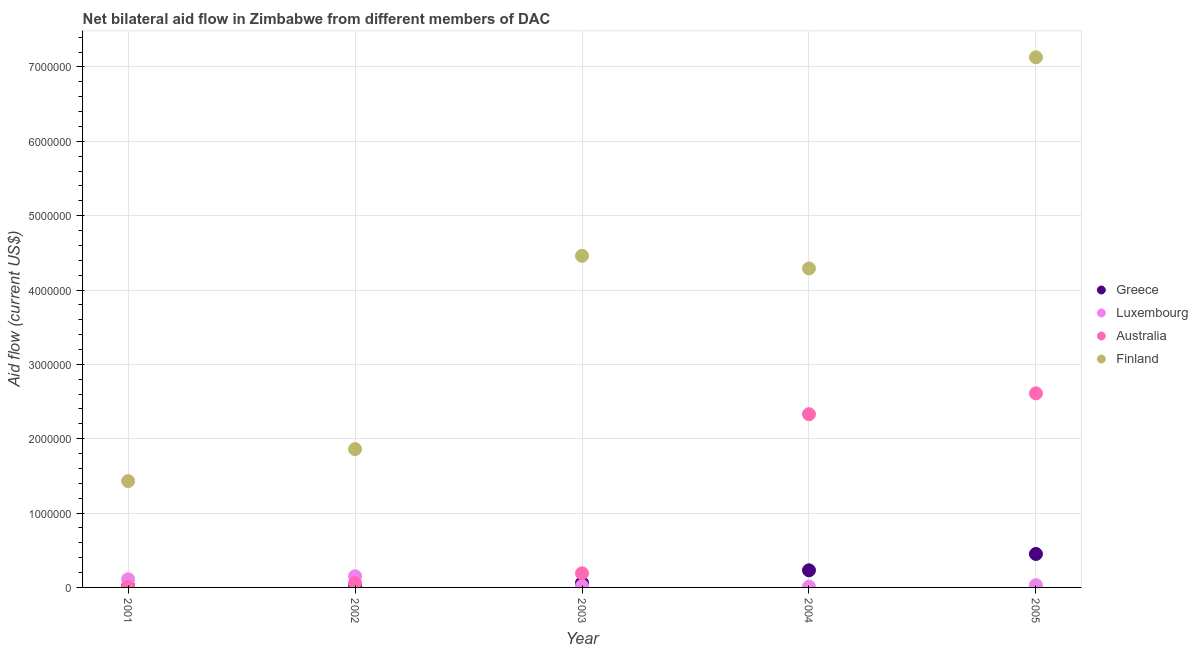What is the amount of aid given by finland in 2002?
Give a very brief answer. 1.86e+06. Across all years, what is the maximum amount of aid given by greece?
Give a very brief answer. 4.50e+05. Across all years, what is the minimum amount of aid given by finland?
Your answer should be very brief. 1.43e+06. In which year was the amount of aid given by luxembourg maximum?
Provide a short and direct response. 2002. What is the total amount of aid given by finland in the graph?
Your response must be concise. 1.92e+07. What is the difference between the amount of aid given by australia in 2003 and that in 2004?
Offer a very short reply. -2.14e+06. What is the difference between the amount of aid given by finland in 2003 and the amount of aid given by greece in 2002?
Offer a very short reply. 4.44e+06. What is the average amount of aid given by finland per year?
Make the answer very short. 3.83e+06. In the year 2005, what is the difference between the amount of aid given by finland and amount of aid given by australia?
Give a very brief answer. 4.52e+06. In how many years, is the amount of aid given by greece greater than 1800000 US$?
Give a very brief answer. 0. What is the ratio of the amount of aid given by greece in 2001 to that in 2003?
Your answer should be compact. 0.33. What is the difference between the highest and the second highest amount of aid given by greece?
Ensure brevity in your answer.  2.20e+05. What is the difference between the highest and the lowest amount of aid given by australia?
Offer a very short reply. 2.60e+06. In how many years, is the amount of aid given by australia greater than the average amount of aid given by australia taken over all years?
Offer a very short reply. 2. Is it the case that in every year, the sum of the amount of aid given by greece and amount of aid given by luxembourg is greater than the amount of aid given by australia?
Make the answer very short. No. Does the amount of aid given by finland monotonically increase over the years?
Your answer should be very brief. No. Is the amount of aid given by luxembourg strictly less than the amount of aid given by finland over the years?
Provide a short and direct response. Yes. How many dotlines are there?
Make the answer very short. 4. What is the difference between two consecutive major ticks on the Y-axis?
Keep it short and to the point. 1.00e+06. Are the values on the major ticks of Y-axis written in scientific E-notation?
Your answer should be compact. No. Does the graph contain any zero values?
Your answer should be very brief. No. What is the title of the graph?
Provide a short and direct response. Net bilateral aid flow in Zimbabwe from different members of DAC. What is the label or title of the Y-axis?
Make the answer very short. Aid flow (current US$). What is the Aid flow (current US$) in Finland in 2001?
Provide a succinct answer. 1.43e+06. What is the Aid flow (current US$) in Luxembourg in 2002?
Provide a short and direct response. 1.50e+05. What is the Aid flow (current US$) of Australia in 2002?
Your answer should be compact. 6.00e+04. What is the Aid flow (current US$) in Finland in 2002?
Provide a short and direct response. 1.86e+06. What is the Aid flow (current US$) of Greece in 2003?
Keep it short and to the point. 6.00e+04. What is the Aid flow (current US$) in Australia in 2003?
Provide a short and direct response. 1.90e+05. What is the Aid flow (current US$) in Finland in 2003?
Keep it short and to the point. 4.46e+06. What is the Aid flow (current US$) of Australia in 2004?
Keep it short and to the point. 2.33e+06. What is the Aid flow (current US$) of Finland in 2004?
Provide a succinct answer. 4.29e+06. What is the Aid flow (current US$) in Australia in 2005?
Ensure brevity in your answer.  2.61e+06. What is the Aid flow (current US$) in Finland in 2005?
Your answer should be very brief. 7.13e+06. Across all years, what is the maximum Aid flow (current US$) in Luxembourg?
Your response must be concise. 1.50e+05. Across all years, what is the maximum Aid flow (current US$) in Australia?
Your answer should be very brief. 2.61e+06. Across all years, what is the maximum Aid flow (current US$) in Finland?
Give a very brief answer. 7.13e+06. Across all years, what is the minimum Aid flow (current US$) in Greece?
Provide a succinct answer. 2.00e+04. Across all years, what is the minimum Aid flow (current US$) of Luxembourg?
Your answer should be very brief. 10000. Across all years, what is the minimum Aid flow (current US$) in Finland?
Your answer should be very brief. 1.43e+06. What is the total Aid flow (current US$) of Greece in the graph?
Your answer should be compact. 7.80e+05. What is the total Aid flow (current US$) in Luxembourg in the graph?
Provide a succinct answer. 3.20e+05. What is the total Aid flow (current US$) in Australia in the graph?
Make the answer very short. 5.20e+06. What is the total Aid flow (current US$) of Finland in the graph?
Your response must be concise. 1.92e+07. What is the difference between the Aid flow (current US$) in Greece in 2001 and that in 2002?
Your response must be concise. 0. What is the difference between the Aid flow (current US$) of Luxembourg in 2001 and that in 2002?
Keep it short and to the point. -4.00e+04. What is the difference between the Aid flow (current US$) of Australia in 2001 and that in 2002?
Keep it short and to the point. -5.00e+04. What is the difference between the Aid flow (current US$) in Finland in 2001 and that in 2002?
Ensure brevity in your answer.  -4.30e+05. What is the difference between the Aid flow (current US$) in Finland in 2001 and that in 2003?
Make the answer very short. -3.03e+06. What is the difference between the Aid flow (current US$) of Greece in 2001 and that in 2004?
Offer a very short reply. -2.10e+05. What is the difference between the Aid flow (current US$) in Luxembourg in 2001 and that in 2004?
Ensure brevity in your answer.  1.00e+05. What is the difference between the Aid flow (current US$) in Australia in 2001 and that in 2004?
Your response must be concise. -2.32e+06. What is the difference between the Aid flow (current US$) of Finland in 2001 and that in 2004?
Make the answer very short. -2.86e+06. What is the difference between the Aid flow (current US$) of Greece in 2001 and that in 2005?
Offer a very short reply. -4.30e+05. What is the difference between the Aid flow (current US$) of Luxembourg in 2001 and that in 2005?
Provide a succinct answer. 8.00e+04. What is the difference between the Aid flow (current US$) in Australia in 2001 and that in 2005?
Make the answer very short. -2.60e+06. What is the difference between the Aid flow (current US$) in Finland in 2001 and that in 2005?
Provide a short and direct response. -5.70e+06. What is the difference between the Aid flow (current US$) of Greece in 2002 and that in 2003?
Offer a very short reply. -4.00e+04. What is the difference between the Aid flow (current US$) in Australia in 2002 and that in 2003?
Give a very brief answer. -1.30e+05. What is the difference between the Aid flow (current US$) in Finland in 2002 and that in 2003?
Give a very brief answer. -2.60e+06. What is the difference between the Aid flow (current US$) of Australia in 2002 and that in 2004?
Your answer should be very brief. -2.27e+06. What is the difference between the Aid flow (current US$) in Finland in 2002 and that in 2004?
Provide a short and direct response. -2.43e+06. What is the difference between the Aid flow (current US$) in Greece in 2002 and that in 2005?
Your answer should be very brief. -4.30e+05. What is the difference between the Aid flow (current US$) of Luxembourg in 2002 and that in 2005?
Provide a short and direct response. 1.20e+05. What is the difference between the Aid flow (current US$) in Australia in 2002 and that in 2005?
Ensure brevity in your answer.  -2.55e+06. What is the difference between the Aid flow (current US$) of Finland in 2002 and that in 2005?
Your response must be concise. -5.27e+06. What is the difference between the Aid flow (current US$) of Luxembourg in 2003 and that in 2004?
Your answer should be very brief. 10000. What is the difference between the Aid flow (current US$) of Australia in 2003 and that in 2004?
Ensure brevity in your answer.  -2.14e+06. What is the difference between the Aid flow (current US$) in Finland in 2003 and that in 2004?
Offer a terse response. 1.70e+05. What is the difference between the Aid flow (current US$) in Greece in 2003 and that in 2005?
Your answer should be very brief. -3.90e+05. What is the difference between the Aid flow (current US$) of Australia in 2003 and that in 2005?
Offer a terse response. -2.42e+06. What is the difference between the Aid flow (current US$) of Finland in 2003 and that in 2005?
Provide a short and direct response. -2.67e+06. What is the difference between the Aid flow (current US$) in Luxembourg in 2004 and that in 2005?
Ensure brevity in your answer.  -2.00e+04. What is the difference between the Aid flow (current US$) in Australia in 2004 and that in 2005?
Make the answer very short. -2.80e+05. What is the difference between the Aid flow (current US$) of Finland in 2004 and that in 2005?
Provide a succinct answer. -2.84e+06. What is the difference between the Aid flow (current US$) in Greece in 2001 and the Aid flow (current US$) in Luxembourg in 2002?
Your answer should be compact. -1.30e+05. What is the difference between the Aid flow (current US$) of Greece in 2001 and the Aid flow (current US$) of Australia in 2002?
Make the answer very short. -4.00e+04. What is the difference between the Aid flow (current US$) in Greece in 2001 and the Aid flow (current US$) in Finland in 2002?
Offer a terse response. -1.84e+06. What is the difference between the Aid flow (current US$) of Luxembourg in 2001 and the Aid flow (current US$) of Finland in 2002?
Make the answer very short. -1.75e+06. What is the difference between the Aid flow (current US$) of Australia in 2001 and the Aid flow (current US$) of Finland in 2002?
Make the answer very short. -1.85e+06. What is the difference between the Aid flow (current US$) of Greece in 2001 and the Aid flow (current US$) of Luxembourg in 2003?
Ensure brevity in your answer.  0. What is the difference between the Aid flow (current US$) of Greece in 2001 and the Aid flow (current US$) of Finland in 2003?
Ensure brevity in your answer.  -4.44e+06. What is the difference between the Aid flow (current US$) in Luxembourg in 2001 and the Aid flow (current US$) in Australia in 2003?
Ensure brevity in your answer.  -8.00e+04. What is the difference between the Aid flow (current US$) of Luxembourg in 2001 and the Aid flow (current US$) of Finland in 2003?
Offer a very short reply. -4.35e+06. What is the difference between the Aid flow (current US$) in Australia in 2001 and the Aid flow (current US$) in Finland in 2003?
Your response must be concise. -4.45e+06. What is the difference between the Aid flow (current US$) of Greece in 2001 and the Aid flow (current US$) of Luxembourg in 2004?
Provide a short and direct response. 10000. What is the difference between the Aid flow (current US$) of Greece in 2001 and the Aid flow (current US$) of Australia in 2004?
Offer a terse response. -2.31e+06. What is the difference between the Aid flow (current US$) in Greece in 2001 and the Aid flow (current US$) in Finland in 2004?
Keep it short and to the point. -4.27e+06. What is the difference between the Aid flow (current US$) of Luxembourg in 2001 and the Aid flow (current US$) of Australia in 2004?
Keep it short and to the point. -2.22e+06. What is the difference between the Aid flow (current US$) of Luxembourg in 2001 and the Aid flow (current US$) of Finland in 2004?
Offer a terse response. -4.18e+06. What is the difference between the Aid flow (current US$) in Australia in 2001 and the Aid flow (current US$) in Finland in 2004?
Offer a very short reply. -4.28e+06. What is the difference between the Aid flow (current US$) of Greece in 2001 and the Aid flow (current US$) of Australia in 2005?
Offer a very short reply. -2.59e+06. What is the difference between the Aid flow (current US$) in Greece in 2001 and the Aid flow (current US$) in Finland in 2005?
Make the answer very short. -7.11e+06. What is the difference between the Aid flow (current US$) in Luxembourg in 2001 and the Aid flow (current US$) in Australia in 2005?
Provide a succinct answer. -2.50e+06. What is the difference between the Aid flow (current US$) in Luxembourg in 2001 and the Aid flow (current US$) in Finland in 2005?
Give a very brief answer. -7.02e+06. What is the difference between the Aid flow (current US$) of Australia in 2001 and the Aid flow (current US$) of Finland in 2005?
Your response must be concise. -7.12e+06. What is the difference between the Aid flow (current US$) of Greece in 2002 and the Aid flow (current US$) of Luxembourg in 2003?
Offer a terse response. 0. What is the difference between the Aid flow (current US$) in Greece in 2002 and the Aid flow (current US$) in Australia in 2003?
Provide a short and direct response. -1.70e+05. What is the difference between the Aid flow (current US$) in Greece in 2002 and the Aid flow (current US$) in Finland in 2003?
Offer a very short reply. -4.44e+06. What is the difference between the Aid flow (current US$) in Luxembourg in 2002 and the Aid flow (current US$) in Australia in 2003?
Offer a very short reply. -4.00e+04. What is the difference between the Aid flow (current US$) in Luxembourg in 2002 and the Aid flow (current US$) in Finland in 2003?
Your answer should be very brief. -4.31e+06. What is the difference between the Aid flow (current US$) in Australia in 2002 and the Aid flow (current US$) in Finland in 2003?
Your response must be concise. -4.40e+06. What is the difference between the Aid flow (current US$) of Greece in 2002 and the Aid flow (current US$) of Australia in 2004?
Your answer should be compact. -2.31e+06. What is the difference between the Aid flow (current US$) of Greece in 2002 and the Aid flow (current US$) of Finland in 2004?
Provide a succinct answer. -4.27e+06. What is the difference between the Aid flow (current US$) in Luxembourg in 2002 and the Aid flow (current US$) in Australia in 2004?
Provide a short and direct response. -2.18e+06. What is the difference between the Aid flow (current US$) in Luxembourg in 2002 and the Aid flow (current US$) in Finland in 2004?
Ensure brevity in your answer.  -4.14e+06. What is the difference between the Aid flow (current US$) in Australia in 2002 and the Aid flow (current US$) in Finland in 2004?
Keep it short and to the point. -4.23e+06. What is the difference between the Aid flow (current US$) in Greece in 2002 and the Aid flow (current US$) in Australia in 2005?
Ensure brevity in your answer.  -2.59e+06. What is the difference between the Aid flow (current US$) in Greece in 2002 and the Aid flow (current US$) in Finland in 2005?
Your response must be concise. -7.11e+06. What is the difference between the Aid flow (current US$) of Luxembourg in 2002 and the Aid flow (current US$) of Australia in 2005?
Provide a succinct answer. -2.46e+06. What is the difference between the Aid flow (current US$) of Luxembourg in 2002 and the Aid flow (current US$) of Finland in 2005?
Your answer should be very brief. -6.98e+06. What is the difference between the Aid flow (current US$) of Australia in 2002 and the Aid flow (current US$) of Finland in 2005?
Provide a succinct answer. -7.07e+06. What is the difference between the Aid flow (current US$) in Greece in 2003 and the Aid flow (current US$) in Australia in 2004?
Keep it short and to the point. -2.27e+06. What is the difference between the Aid flow (current US$) in Greece in 2003 and the Aid flow (current US$) in Finland in 2004?
Keep it short and to the point. -4.23e+06. What is the difference between the Aid flow (current US$) in Luxembourg in 2003 and the Aid flow (current US$) in Australia in 2004?
Your response must be concise. -2.31e+06. What is the difference between the Aid flow (current US$) of Luxembourg in 2003 and the Aid flow (current US$) of Finland in 2004?
Your answer should be very brief. -4.27e+06. What is the difference between the Aid flow (current US$) in Australia in 2003 and the Aid flow (current US$) in Finland in 2004?
Give a very brief answer. -4.10e+06. What is the difference between the Aid flow (current US$) in Greece in 2003 and the Aid flow (current US$) in Luxembourg in 2005?
Give a very brief answer. 3.00e+04. What is the difference between the Aid flow (current US$) in Greece in 2003 and the Aid flow (current US$) in Australia in 2005?
Provide a short and direct response. -2.55e+06. What is the difference between the Aid flow (current US$) of Greece in 2003 and the Aid flow (current US$) of Finland in 2005?
Your response must be concise. -7.07e+06. What is the difference between the Aid flow (current US$) in Luxembourg in 2003 and the Aid flow (current US$) in Australia in 2005?
Your answer should be compact. -2.59e+06. What is the difference between the Aid flow (current US$) of Luxembourg in 2003 and the Aid flow (current US$) of Finland in 2005?
Give a very brief answer. -7.11e+06. What is the difference between the Aid flow (current US$) of Australia in 2003 and the Aid flow (current US$) of Finland in 2005?
Offer a very short reply. -6.94e+06. What is the difference between the Aid flow (current US$) of Greece in 2004 and the Aid flow (current US$) of Australia in 2005?
Your response must be concise. -2.38e+06. What is the difference between the Aid flow (current US$) of Greece in 2004 and the Aid flow (current US$) of Finland in 2005?
Your answer should be very brief. -6.90e+06. What is the difference between the Aid flow (current US$) in Luxembourg in 2004 and the Aid flow (current US$) in Australia in 2005?
Your answer should be compact. -2.60e+06. What is the difference between the Aid flow (current US$) of Luxembourg in 2004 and the Aid flow (current US$) of Finland in 2005?
Give a very brief answer. -7.12e+06. What is the difference between the Aid flow (current US$) in Australia in 2004 and the Aid flow (current US$) in Finland in 2005?
Offer a very short reply. -4.80e+06. What is the average Aid flow (current US$) in Greece per year?
Keep it short and to the point. 1.56e+05. What is the average Aid flow (current US$) in Luxembourg per year?
Keep it short and to the point. 6.40e+04. What is the average Aid flow (current US$) of Australia per year?
Provide a succinct answer. 1.04e+06. What is the average Aid flow (current US$) of Finland per year?
Your response must be concise. 3.83e+06. In the year 2001, what is the difference between the Aid flow (current US$) in Greece and Aid flow (current US$) in Australia?
Your answer should be very brief. 10000. In the year 2001, what is the difference between the Aid flow (current US$) in Greece and Aid flow (current US$) in Finland?
Give a very brief answer. -1.41e+06. In the year 2001, what is the difference between the Aid flow (current US$) of Luxembourg and Aid flow (current US$) of Australia?
Make the answer very short. 1.00e+05. In the year 2001, what is the difference between the Aid flow (current US$) in Luxembourg and Aid flow (current US$) in Finland?
Provide a succinct answer. -1.32e+06. In the year 2001, what is the difference between the Aid flow (current US$) in Australia and Aid flow (current US$) in Finland?
Offer a terse response. -1.42e+06. In the year 2002, what is the difference between the Aid flow (current US$) of Greece and Aid flow (current US$) of Finland?
Keep it short and to the point. -1.84e+06. In the year 2002, what is the difference between the Aid flow (current US$) of Luxembourg and Aid flow (current US$) of Finland?
Ensure brevity in your answer.  -1.71e+06. In the year 2002, what is the difference between the Aid flow (current US$) of Australia and Aid flow (current US$) of Finland?
Keep it short and to the point. -1.80e+06. In the year 2003, what is the difference between the Aid flow (current US$) in Greece and Aid flow (current US$) in Luxembourg?
Give a very brief answer. 4.00e+04. In the year 2003, what is the difference between the Aid flow (current US$) in Greece and Aid flow (current US$) in Australia?
Ensure brevity in your answer.  -1.30e+05. In the year 2003, what is the difference between the Aid flow (current US$) in Greece and Aid flow (current US$) in Finland?
Give a very brief answer. -4.40e+06. In the year 2003, what is the difference between the Aid flow (current US$) in Luxembourg and Aid flow (current US$) in Australia?
Offer a very short reply. -1.70e+05. In the year 2003, what is the difference between the Aid flow (current US$) in Luxembourg and Aid flow (current US$) in Finland?
Your answer should be very brief. -4.44e+06. In the year 2003, what is the difference between the Aid flow (current US$) of Australia and Aid flow (current US$) of Finland?
Provide a short and direct response. -4.27e+06. In the year 2004, what is the difference between the Aid flow (current US$) of Greece and Aid flow (current US$) of Australia?
Make the answer very short. -2.10e+06. In the year 2004, what is the difference between the Aid flow (current US$) in Greece and Aid flow (current US$) in Finland?
Make the answer very short. -4.06e+06. In the year 2004, what is the difference between the Aid flow (current US$) in Luxembourg and Aid flow (current US$) in Australia?
Your answer should be very brief. -2.32e+06. In the year 2004, what is the difference between the Aid flow (current US$) of Luxembourg and Aid flow (current US$) of Finland?
Offer a very short reply. -4.28e+06. In the year 2004, what is the difference between the Aid flow (current US$) of Australia and Aid flow (current US$) of Finland?
Keep it short and to the point. -1.96e+06. In the year 2005, what is the difference between the Aid flow (current US$) of Greece and Aid flow (current US$) of Australia?
Keep it short and to the point. -2.16e+06. In the year 2005, what is the difference between the Aid flow (current US$) in Greece and Aid flow (current US$) in Finland?
Ensure brevity in your answer.  -6.68e+06. In the year 2005, what is the difference between the Aid flow (current US$) of Luxembourg and Aid flow (current US$) of Australia?
Offer a very short reply. -2.58e+06. In the year 2005, what is the difference between the Aid flow (current US$) in Luxembourg and Aid flow (current US$) in Finland?
Offer a terse response. -7.10e+06. In the year 2005, what is the difference between the Aid flow (current US$) in Australia and Aid flow (current US$) in Finland?
Your response must be concise. -4.52e+06. What is the ratio of the Aid flow (current US$) of Luxembourg in 2001 to that in 2002?
Your answer should be very brief. 0.73. What is the ratio of the Aid flow (current US$) of Australia in 2001 to that in 2002?
Keep it short and to the point. 0.17. What is the ratio of the Aid flow (current US$) of Finland in 2001 to that in 2002?
Offer a terse response. 0.77. What is the ratio of the Aid flow (current US$) in Australia in 2001 to that in 2003?
Provide a succinct answer. 0.05. What is the ratio of the Aid flow (current US$) in Finland in 2001 to that in 2003?
Your answer should be very brief. 0.32. What is the ratio of the Aid flow (current US$) in Greece in 2001 to that in 2004?
Your answer should be compact. 0.09. What is the ratio of the Aid flow (current US$) in Luxembourg in 2001 to that in 2004?
Ensure brevity in your answer.  11. What is the ratio of the Aid flow (current US$) in Australia in 2001 to that in 2004?
Provide a short and direct response. 0. What is the ratio of the Aid flow (current US$) in Finland in 2001 to that in 2004?
Provide a short and direct response. 0.33. What is the ratio of the Aid flow (current US$) of Greece in 2001 to that in 2005?
Ensure brevity in your answer.  0.04. What is the ratio of the Aid flow (current US$) of Luxembourg in 2001 to that in 2005?
Your response must be concise. 3.67. What is the ratio of the Aid flow (current US$) in Australia in 2001 to that in 2005?
Offer a very short reply. 0. What is the ratio of the Aid flow (current US$) of Finland in 2001 to that in 2005?
Make the answer very short. 0.2. What is the ratio of the Aid flow (current US$) of Luxembourg in 2002 to that in 2003?
Your answer should be compact. 7.5. What is the ratio of the Aid flow (current US$) of Australia in 2002 to that in 2003?
Your answer should be very brief. 0.32. What is the ratio of the Aid flow (current US$) of Finland in 2002 to that in 2003?
Give a very brief answer. 0.42. What is the ratio of the Aid flow (current US$) in Greece in 2002 to that in 2004?
Provide a succinct answer. 0.09. What is the ratio of the Aid flow (current US$) in Luxembourg in 2002 to that in 2004?
Provide a succinct answer. 15. What is the ratio of the Aid flow (current US$) of Australia in 2002 to that in 2004?
Offer a very short reply. 0.03. What is the ratio of the Aid flow (current US$) of Finland in 2002 to that in 2004?
Offer a very short reply. 0.43. What is the ratio of the Aid flow (current US$) of Greece in 2002 to that in 2005?
Ensure brevity in your answer.  0.04. What is the ratio of the Aid flow (current US$) of Australia in 2002 to that in 2005?
Ensure brevity in your answer.  0.02. What is the ratio of the Aid flow (current US$) in Finland in 2002 to that in 2005?
Give a very brief answer. 0.26. What is the ratio of the Aid flow (current US$) of Greece in 2003 to that in 2004?
Make the answer very short. 0.26. What is the ratio of the Aid flow (current US$) of Luxembourg in 2003 to that in 2004?
Your answer should be compact. 2. What is the ratio of the Aid flow (current US$) of Australia in 2003 to that in 2004?
Offer a terse response. 0.08. What is the ratio of the Aid flow (current US$) of Finland in 2003 to that in 2004?
Keep it short and to the point. 1.04. What is the ratio of the Aid flow (current US$) in Greece in 2003 to that in 2005?
Provide a short and direct response. 0.13. What is the ratio of the Aid flow (current US$) in Luxembourg in 2003 to that in 2005?
Provide a short and direct response. 0.67. What is the ratio of the Aid flow (current US$) of Australia in 2003 to that in 2005?
Your answer should be compact. 0.07. What is the ratio of the Aid flow (current US$) in Finland in 2003 to that in 2005?
Ensure brevity in your answer.  0.63. What is the ratio of the Aid flow (current US$) of Greece in 2004 to that in 2005?
Provide a short and direct response. 0.51. What is the ratio of the Aid flow (current US$) of Australia in 2004 to that in 2005?
Make the answer very short. 0.89. What is the ratio of the Aid flow (current US$) in Finland in 2004 to that in 2005?
Provide a short and direct response. 0.6. What is the difference between the highest and the second highest Aid flow (current US$) in Finland?
Provide a short and direct response. 2.67e+06. What is the difference between the highest and the lowest Aid flow (current US$) in Australia?
Ensure brevity in your answer.  2.60e+06. What is the difference between the highest and the lowest Aid flow (current US$) of Finland?
Make the answer very short. 5.70e+06. 